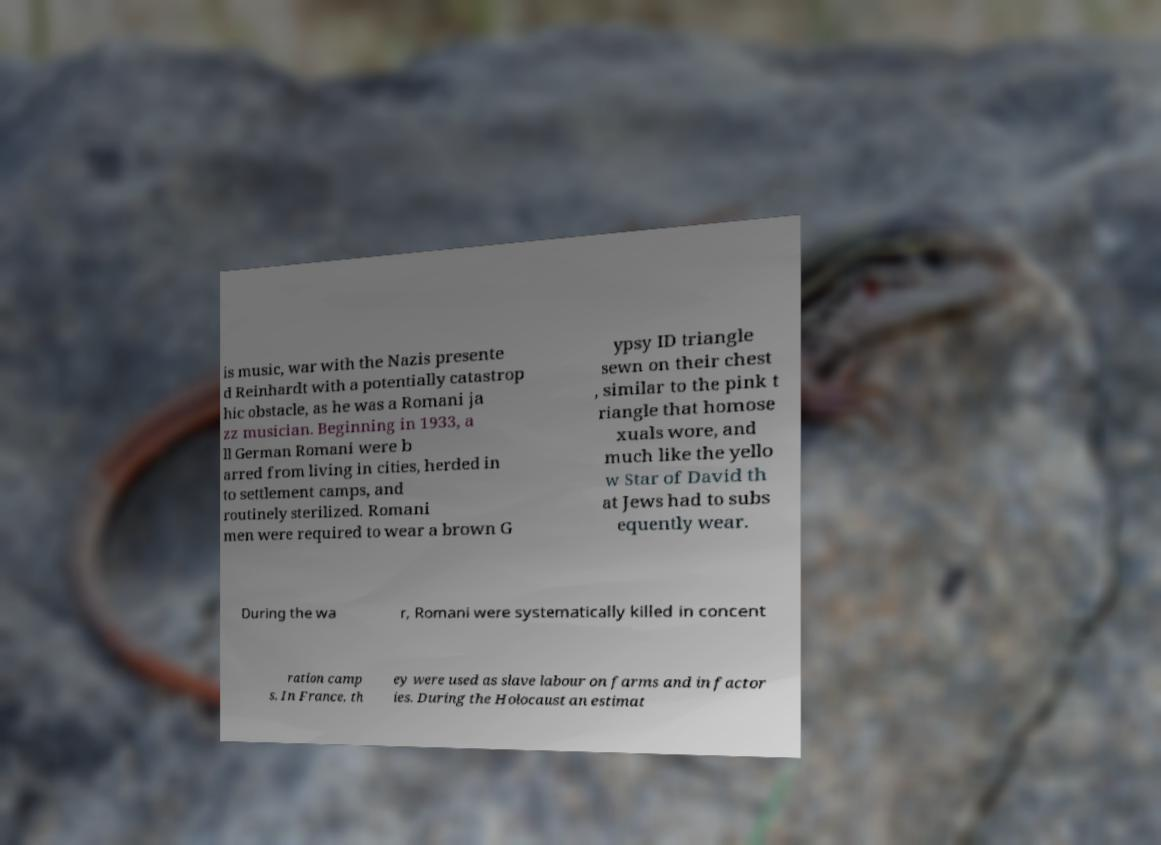Could you extract and type out the text from this image? is music, war with the Nazis presente d Reinhardt with a potentially catastrop hic obstacle, as he was a Romani ja zz musician. Beginning in 1933, a ll German Romani were b arred from living in cities, herded in to settlement camps, and routinely sterilized. Romani men were required to wear a brown G ypsy ID triangle sewn on their chest , similar to the pink t riangle that homose xuals wore, and much like the yello w Star of David th at Jews had to subs equently wear. During the wa r, Romani were systematically killed in concent ration camp s. In France, th ey were used as slave labour on farms and in factor ies. During the Holocaust an estimat 